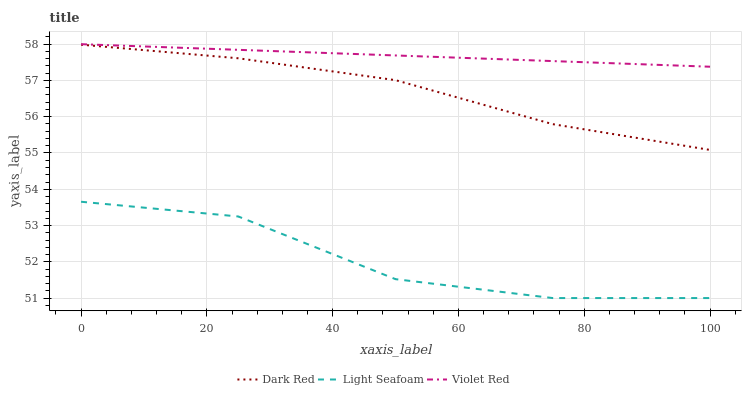Does Light Seafoam have the minimum area under the curve?
Answer yes or no. Yes. Does Violet Red have the maximum area under the curve?
Answer yes or no. Yes. Does Violet Red have the minimum area under the curve?
Answer yes or no. No. Does Light Seafoam have the maximum area under the curve?
Answer yes or no. No. Is Violet Red the smoothest?
Answer yes or no. Yes. Is Light Seafoam the roughest?
Answer yes or no. Yes. Is Light Seafoam the smoothest?
Answer yes or no. No. Is Violet Red the roughest?
Answer yes or no. No. Does Light Seafoam have the lowest value?
Answer yes or no. Yes. Does Violet Red have the lowest value?
Answer yes or no. No. Does Violet Red have the highest value?
Answer yes or no. Yes. Does Light Seafoam have the highest value?
Answer yes or no. No. Is Light Seafoam less than Dark Red?
Answer yes or no. Yes. Is Dark Red greater than Light Seafoam?
Answer yes or no. Yes. Does Light Seafoam intersect Dark Red?
Answer yes or no. No. 